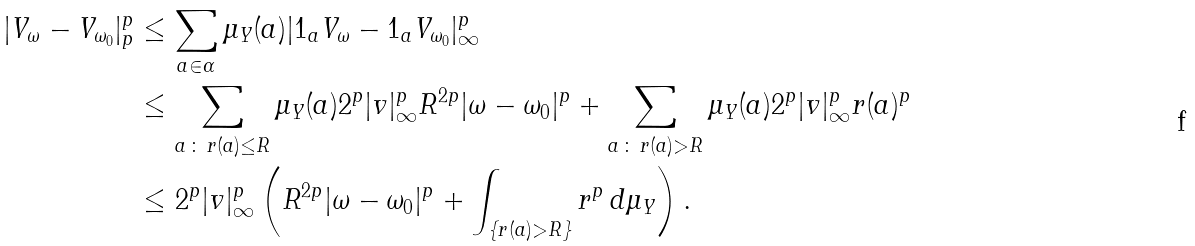<formula> <loc_0><loc_0><loc_500><loc_500>| V _ { \omega } - V _ { \omega _ { 0 } } | _ { p } ^ { p } & \leq \sum _ { a \in \alpha } \mu _ { Y } ( a ) | 1 _ { a } V _ { \omega } - 1 _ { a } V _ { \omega _ { 0 } } | _ { \infty } ^ { p } \\ & \leq \sum _ { a \, \colon \, r ( a ) \leq R } \mu _ { Y } ( a ) 2 ^ { p } | v | _ { \infty } ^ { p } R ^ { 2 p } | \omega - \omega _ { 0 } | ^ { p } + \sum _ { a \, \colon \, r ( a ) > R } \mu _ { Y } ( a ) 2 ^ { p } | v | _ { \infty } ^ { p } r ( a ) ^ { p } \\ & \leq 2 ^ { p } | v | _ { \infty } ^ { p } \left ( R ^ { 2 p } | \omega - \omega _ { 0 } | ^ { p } + \int _ { \{ r ( a ) > R \} } r ^ { p } \, d \mu _ { Y } \right ) .</formula> 